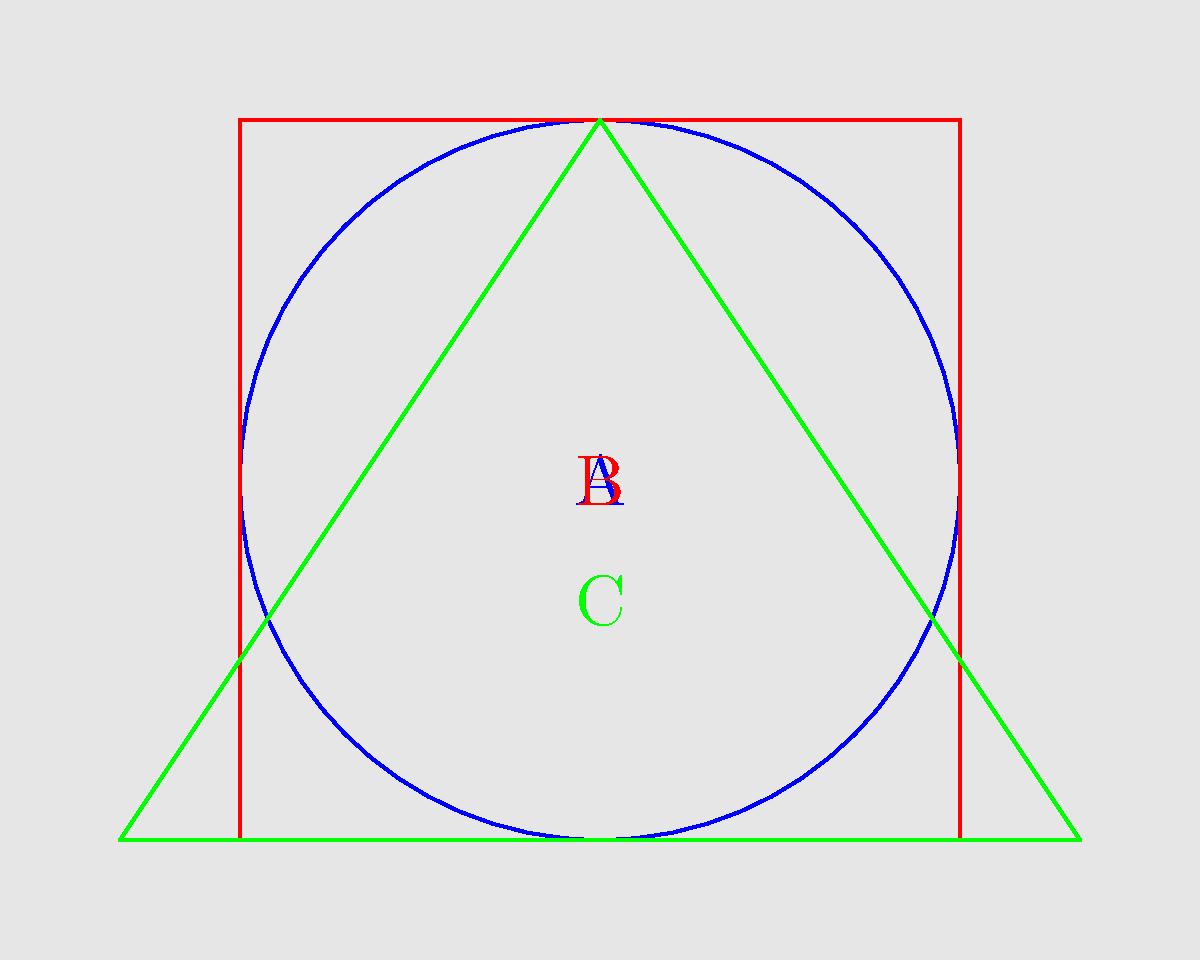You are planning to install a rooftop garden on your newly acquired Haussmann-style building in Paris. Given the constraints of Parisian building regulations and the desire to maximize usable space, which of the following shapes (A, B, or C) would be most efficient for the rooftop garden in terms of area-to-perimeter ratio? To determine the most efficient shape for the rooftop garden, we need to compare the area-to-perimeter ratios of the given shapes. The shape with the highest ratio will be the most efficient.

Let's assume the rooftop has dimensions of 60m x 60m for our calculations.

1. Circle (Shape A):
   Area: $A = \pi r^2 = \pi (30)^2 = 2827.43 \text{ m}^2$
   Perimeter: $P = 2\pi r = 2\pi (30) = 188.50 \text{ m}$
   Ratio: $\frac{A}{P} = \frac{2827.43}{188.50} = 15.00$

2. Square (Shape B):
   Area: $A = s^2 = 60^2 = 3600 \text{ m}^2$
   Perimeter: $P = 4s = 4(60) = 240 \text{ m}$
   Ratio: $\frac{A}{P} = \frac{3600}{240} = 15.00$

3. Triangle (Shape C):
   Area: $A = \frac{1}{2}bh = \frac{1}{2}(80)(60) = 2400 \text{ m}^2$
   Perimeter: $P = 80 + 2\sqrt{40^2 + 60^2} = 80 + 2(72.11) = 224.22 \text{ m}$
   Ratio: $\frac{A}{P} = \frac{2400}{224.22} = 10.70$

The circle (A) and square (B) have the same area-to-perimeter ratio, which is higher than the triangle's (C) ratio. However, considering Parisian building regulations and the practicality of using the space, the square shape (B) would be the most efficient choice. It maximizes usable space while maintaining a high area-to-perimeter ratio, making it easier to design and implement the rooftop garden.
Answer: B (Square) 